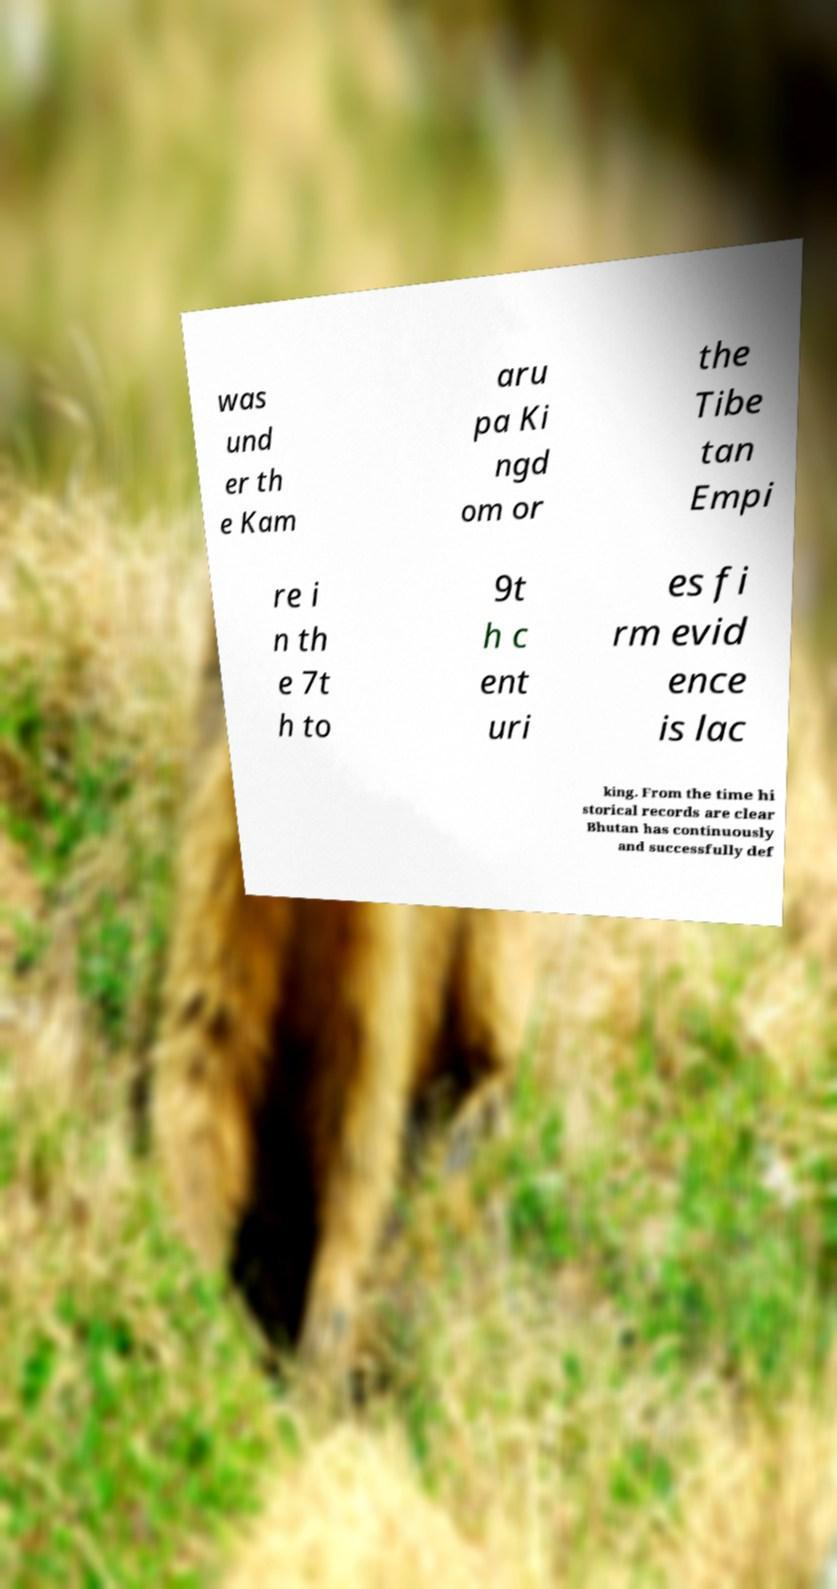Can you accurately transcribe the text from the provided image for me? was und er th e Kam aru pa Ki ngd om or the Tibe tan Empi re i n th e 7t h to 9t h c ent uri es fi rm evid ence is lac king. From the time hi storical records are clear Bhutan has continuously and successfully def 